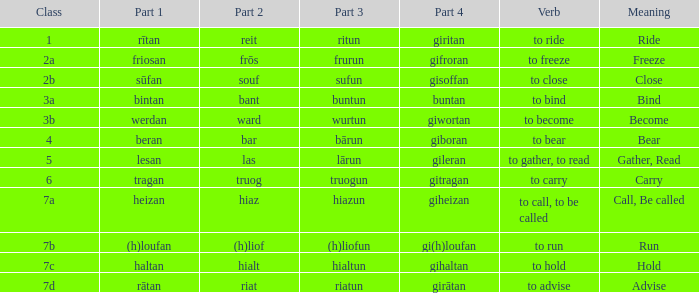What is the part 4 when part 1 is "lesan"? Gileran. 